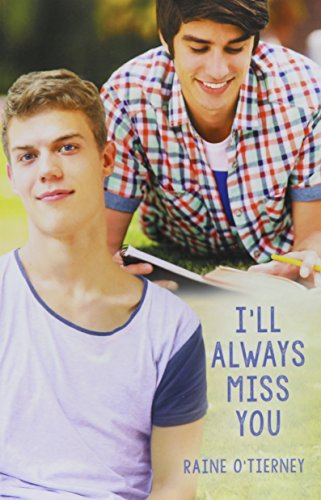What is the genre of this book? The genre of this book is 'Teen & Young Adult', a category focused on characters and narratives that resonate with teenagers and young adults. 